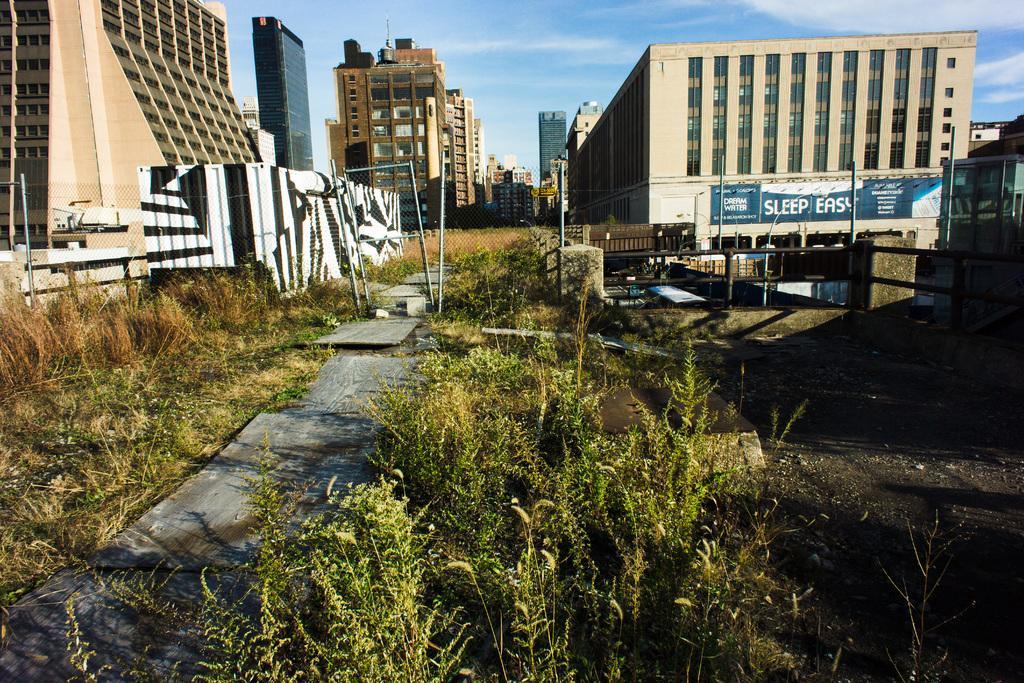Can you describe this image briefly? This image consists of many buildings. At the bottom, there are plants. In the front, we can see the pillars and poles. At the top, there is sky. At the bottom, there is ground. 